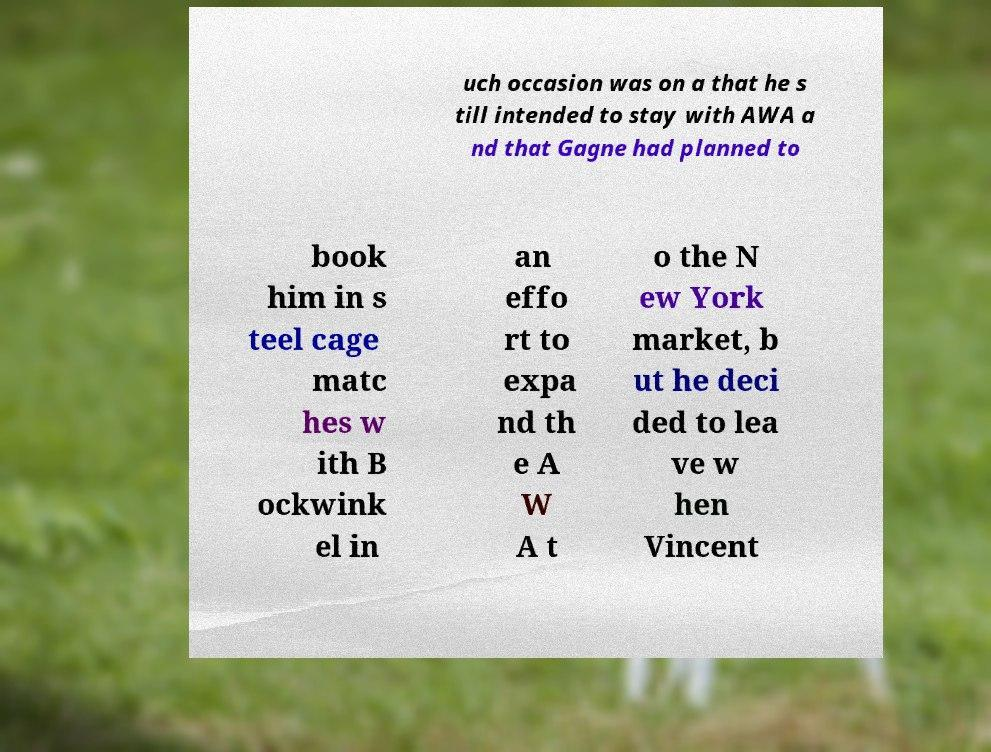Please identify and transcribe the text found in this image. uch occasion was on a that he s till intended to stay with AWA a nd that Gagne had planned to book him in s teel cage matc hes w ith B ockwink el in an effo rt to expa nd th e A W A t o the N ew York market, b ut he deci ded to lea ve w hen Vincent 